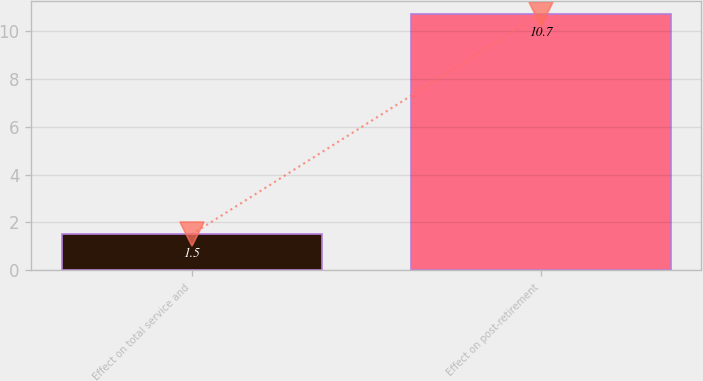<chart> <loc_0><loc_0><loc_500><loc_500><bar_chart><fcel>Effect on total service and<fcel>Effect on post-retirement<nl><fcel>1.5<fcel>10.7<nl></chart> 